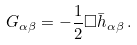<formula> <loc_0><loc_0><loc_500><loc_500>G _ { \alpha \beta } = - \frac { 1 } { 2 } \Box { \bar { h } } _ { \alpha \beta } \, .</formula> 